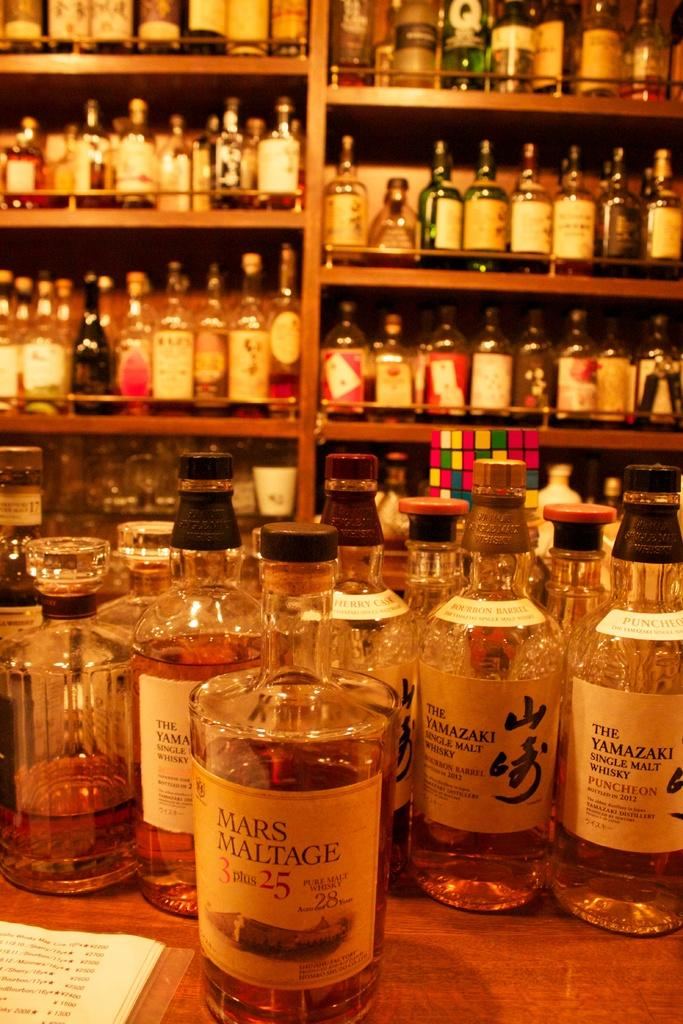What objects are present on the table in the image? There are many bottles and a book on the table in the image. What can be observed about the bottles? The bottles have labels on them. Where are the bottles arranged in the image? Many bottles are arranged on the table, and some are also arranged in a shelf. What type of calculator is being used by the writer in the image? There is no calculator or writer present in the image; it only features bottles and a book. 